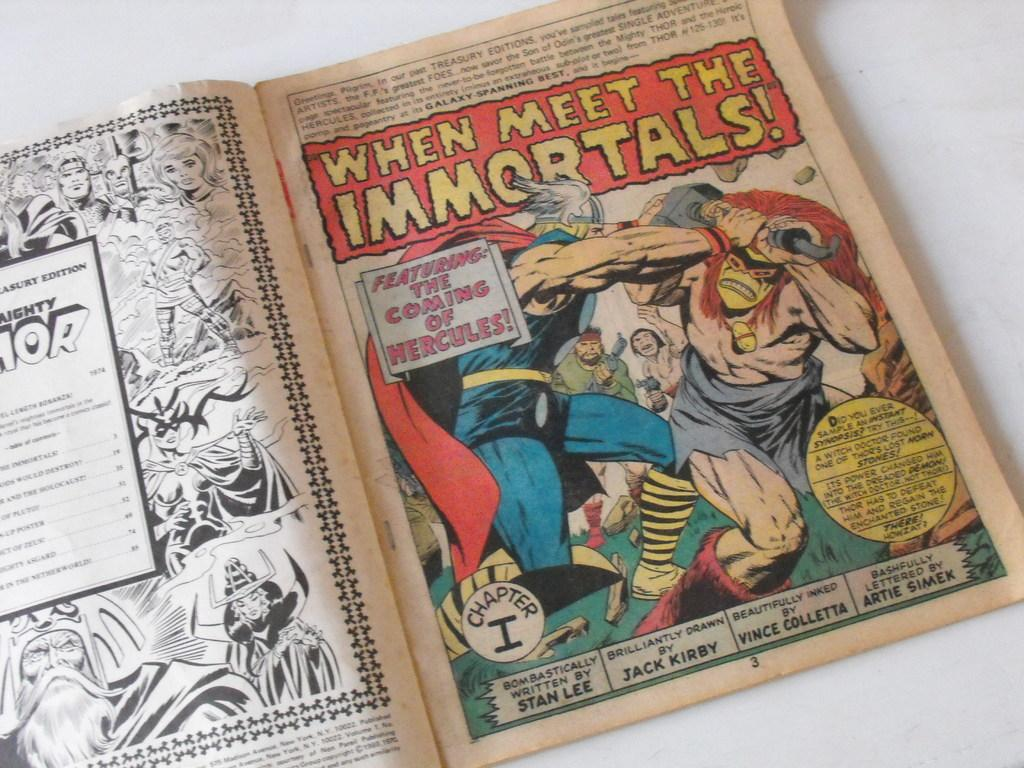<image>
Provide a brief description of the given image. A comic book is turned to a page that says,"When Meet the Immortals!" 